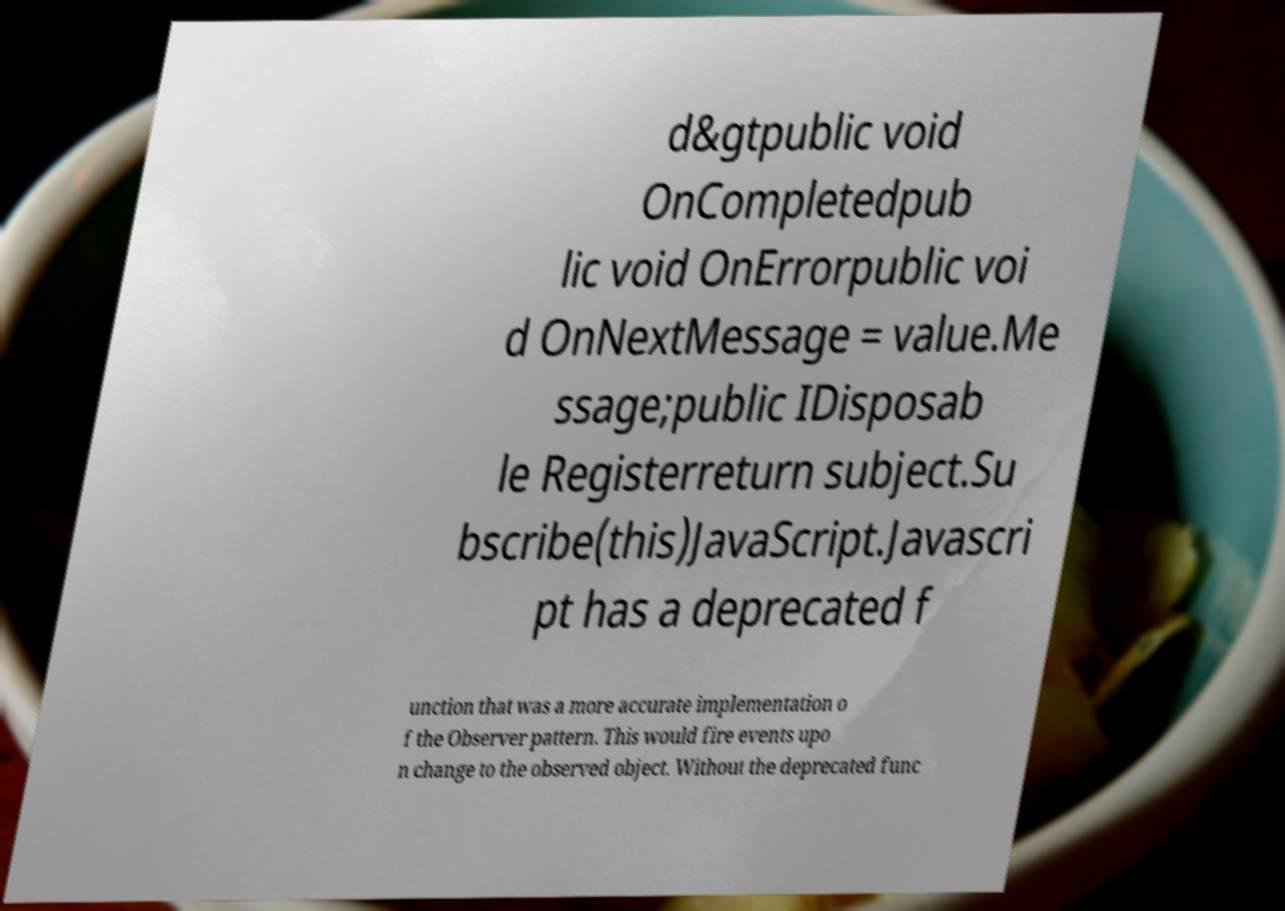Please read and relay the text visible in this image. What does it say? d&gtpublic void OnCompletedpub lic void OnErrorpublic voi d OnNextMessage = value.Me ssage;public IDisposab le Registerreturn subject.Su bscribe(this)JavaScript.Javascri pt has a deprecated f unction that was a more accurate implementation o f the Observer pattern. This would fire events upo n change to the observed object. Without the deprecated func 